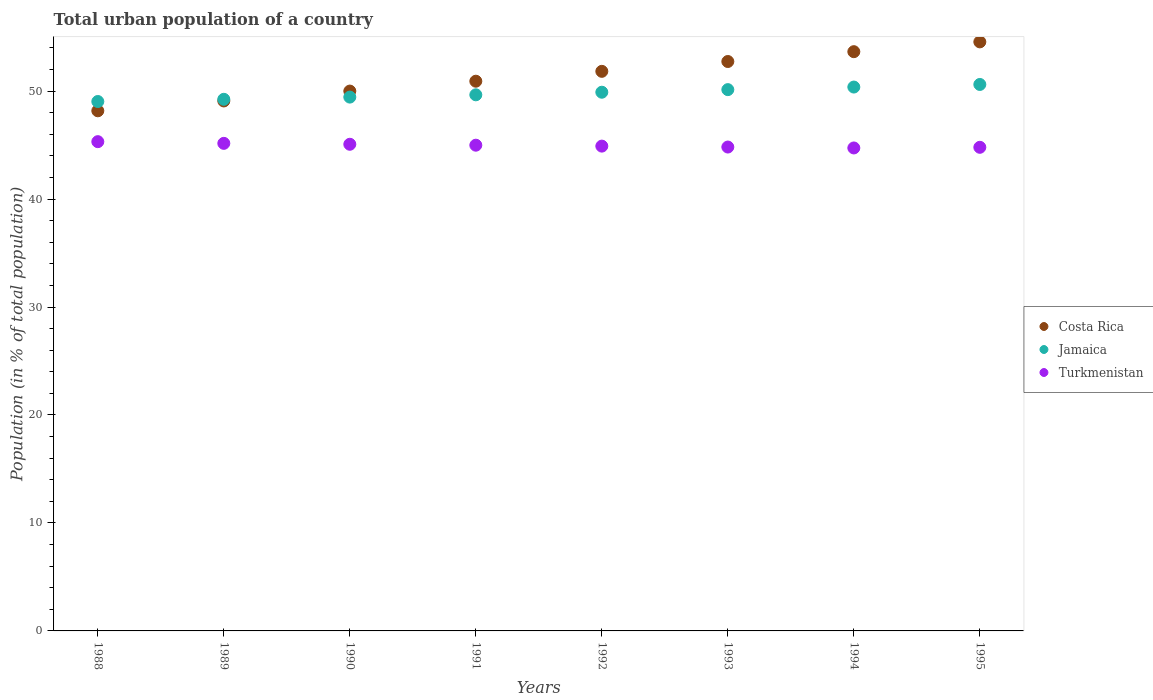What is the urban population in Costa Rica in 1994?
Offer a very short reply. 53.65. Across all years, what is the maximum urban population in Turkmenistan?
Provide a succinct answer. 45.32. Across all years, what is the minimum urban population in Turkmenistan?
Keep it short and to the point. 44.73. In which year was the urban population in Turkmenistan minimum?
Your response must be concise. 1994. What is the total urban population in Jamaica in the graph?
Give a very brief answer. 398.4. What is the difference between the urban population in Costa Rica in 1989 and that in 1991?
Your response must be concise. -1.83. What is the difference between the urban population in Costa Rica in 1991 and the urban population in Jamaica in 1990?
Provide a succinct answer. 1.47. What is the average urban population in Costa Rica per year?
Provide a succinct answer. 51.37. In the year 1990, what is the difference between the urban population in Jamaica and urban population in Costa Rica?
Make the answer very short. -0.56. What is the ratio of the urban population in Jamaica in 1994 to that in 1995?
Your answer should be compact. 1. Is the urban population in Costa Rica in 1988 less than that in 1994?
Give a very brief answer. Yes. Is the difference between the urban population in Jamaica in 1990 and 1992 greater than the difference between the urban population in Costa Rica in 1990 and 1992?
Your answer should be very brief. Yes. What is the difference between the highest and the second highest urban population in Costa Rica?
Provide a succinct answer. 0.91. What is the difference between the highest and the lowest urban population in Turkmenistan?
Your answer should be compact. 0.58. Is the sum of the urban population in Costa Rica in 1989 and 1990 greater than the maximum urban population in Jamaica across all years?
Give a very brief answer. Yes. Is it the case that in every year, the sum of the urban population in Turkmenistan and urban population in Costa Rica  is greater than the urban population in Jamaica?
Offer a terse response. Yes. Is the urban population in Costa Rica strictly greater than the urban population in Turkmenistan over the years?
Ensure brevity in your answer.  Yes. How many years are there in the graph?
Ensure brevity in your answer.  8. Are the values on the major ticks of Y-axis written in scientific E-notation?
Keep it short and to the point. No. Does the graph contain any zero values?
Keep it short and to the point. No. Does the graph contain grids?
Offer a very short reply. No. How are the legend labels stacked?
Give a very brief answer. Vertical. What is the title of the graph?
Provide a succinct answer. Total urban population of a country. What is the label or title of the Y-axis?
Ensure brevity in your answer.  Population (in % of total population). What is the Population (in % of total population) in Costa Rica in 1988?
Give a very brief answer. 48.18. What is the Population (in % of total population) of Jamaica in 1988?
Your answer should be compact. 49.04. What is the Population (in % of total population) of Turkmenistan in 1988?
Your answer should be compact. 45.32. What is the Population (in % of total population) of Costa Rica in 1989?
Offer a terse response. 49.09. What is the Population (in % of total population) of Jamaica in 1989?
Ensure brevity in your answer.  49.24. What is the Population (in % of total population) in Turkmenistan in 1989?
Give a very brief answer. 45.16. What is the Population (in % of total population) of Costa Rica in 1990?
Offer a very short reply. 50. What is the Population (in % of total population) in Jamaica in 1990?
Give a very brief answer. 49.44. What is the Population (in % of total population) of Turkmenistan in 1990?
Provide a short and direct response. 45.08. What is the Population (in % of total population) in Costa Rica in 1991?
Offer a terse response. 50.92. What is the Population (in % of total population) of Jamaica in 1991?
Provide a succinct answer. 49.66. What is the Population (in % of total population) in Turkmenistan in 1991?
Provide a succinct answer. 44.99. What is the Population (in % of total population) of Costa Rica in 1992?
Provide a short and direct response. 51.83. What is the Population (in % of total population) of Jamaica in 1992?
Keep it short and to the point. 49.9. What is the Population (in % of total population) of Turkmenistan in 1992?
Your answer should be compact. 44.9. What is the Population (in % of total population) of Costa Rica in 1993?
Your answer should be very brief. 52.74. What is the Population (in % of total population) of Jamaica in 1993?
Provide a succinct answer. 50.14. What is the Population (in % of total population) in Turkmenistan in 1993?
Ensure brevity in your answer.  44.82. What is the Population (in % of total population) in Costa Rica in 1994?
Ensure brevity in your answer.  53.65. What is the Population (in % of total population) in Jamaica in 1994?
Keep it short and to the point. 50.38. What is the Population (in % of total population) of Turkmenistan in 1994?
Provide a succinct answer. 44.73. What is the Population (in % of total population) of Costa Rica in 1995?
Your answer should be very brief. 54.56. What is the Population (in % of total population) in Jamaica in 1995?
Ensure brevity in your answer.  50.62. What is the Population (in % of total population) in Turkmenistan in 1995?
Offer a very short reply. 44.79. Across all years, what is the maximum Population (in % of total population) of Costa Rica?
Ensure brevity in your answer.  54.56. Across all years, what is the maximum Population (in % of total population) in Jamaica?
Offer a very short reply. 50.62. Across all years, what is the maximum Population (in % of total population) of Turkmenistan?
Your answer should be very brief. 45.32. Across all years, what is the minimum Population (in % of total population) of Costa Rica?
Provide a succinct answer. 48.18. Across all years, what is the minimum Population (in % of total population) of Jamaica?
Your answer should be very brief. 49.04. Across all years, what is the minimum Population (in % of total population) in Turkmenistan?
Make the answer very short. 44.73. What is the total Population (in % of total population) of Costa Rica in the graph?
Offer a very short reply. 410.96. What is the total Population (in % of total population) in Jamaica in the graph?
Ensure brevity in your answer.  398.4. What is the total Population (in % of total population) in Turkmenistan in the graph?
Make the answer very short. 359.79. What is the difference between the Population (in % of total population) in Costa Rica in 1988 and that in 1989?
Make the answer very short. -0.91. What is the difference between the Population (in % of total population) of Jamaica in 1988 and that in 1989?
Provide a short and direct response. -0.2. What is the difference between the Population (in % of total population) in Turkmenistan in 1988 and that in 1989?
Your answer should be very brief. 0.16. What is the difference between the Population (in % of total population) in Costa Rica in 1988 and that in 1990?
Make the answer very short. -1.83. What is the difference between the Population (in % of total population) of Jamaica in 1988 and that in 1990?
Your answer should be compact. -0.41. What is the difference between the Population (in % of total population) of Turkmenistan in 1988 and that in 1990?
Keep it short and to the point. 0.24. What is the difference between the Population (in % of total population) of Costa Rica in 1988 and that in 1991?
Your answer should be compact. -2.74. What is the difference between the Population (in % of total population) in Jamaica in 1988 and that in 1991?
Your answer should be compact. -0.62. What is the difference between the Population (in % of total population) of Turkmenistan in 1988 and that in 1991?
Your answer should be very brief. 0.33. What is the difference between the Population (in % of total population) of Costa Rica in 1988 and that in 1992?
Your answer should be very brief. -3.65. What is the difference between the Population (in % of total population) in Jamaica in 1988 and that in 1992?
Offer a very short reply. -0.86. What is the difference between the Population (in % of total population) in Turkmenistan in 1988 and that in 1992?
Offer a terse response. 0.41. What is the difference between the Population (in % of total population) in Costa Rica in 1988 and that in 1993?
Your answer should be compact. -4.57. What is the difference between the Population (in % of total population) in Turkmenistan in 1988 and that in 1993?
Your answer should be compact. 0.5. What is the difference between the Population (in % of total population) of Costa Rica in 1988 and that in 1994?
Make the answer very short. -5.47. What is the difference between the Population (in % of total population) in Jamaica in 1988 and that in 1994?
Your answer should be very brief. -1.34. What is the difference between the Population (in % of total population) of Turkmenistan in 1988 and that in 1994?
Ensure brevity in your answer.  0.58. What is the difference between the Population (in % of total population) in Costa Rica in 1988 and that in 1995?
Your response must be concise. -6.38. What is the difference between the Population (in % of total population) in Jamaica in 1988 and that in 1995?
Your answer should be very brief. -1.58. What is the difference between the Population (in % of total population) in Turkmenistan in 1988 and that in 1995?
Your answer should be very brief. 0.52. What is the difference between the Population (in % of total population) in Costa Rica in 1989 and that in 1990?
Give a very brief answer. -0.91. What is the difference between the Population (in % of total population) in Jamaica in 1989 and that in 1990?
Provide a succinct answer. -0.2. What is the difference between the Population (in % of total population) of Turkmenistan in 1989 and that in 1990?
Offer a terse response. 0.09. What is the difference between the Population (in % of total population) of Costa Rica in 1989 and that in 1991?
Make the answer very short. -1.83. What is the difference between the Population (in % of total population) of Jamaica in 1989 and that in 1991?
Offer a terse response. -0.42. What is the difference between the Population (in % of total population) of Turkmenistan in 1989 and that in 1991?
Provide a succinct answer. 0.17. What is the difference between the Population (in % of total population) of Costa Rica in 1989 and that in 1992?
Offer a very short reply. -2.74. What is the difference between the Population (in % of total population) of Jamaica in 1989 and that in 1992?
Offer a terse response. -0.66. What is the difference between the Population (in % of total population) in Turkmenistan in 1989 and that in 1992?
Offer a terse response. 0.26. What is the difference between the Population (in % of total population) in Costa Rica in 1989 and that in 1993?
Provide a short and direct response. -3.65. What is the difference between the Population (in % of total population) in Jamaica in 1989 and that in 1993?
Make the answer very short. -0.9. What is the difference between the Population (in % of total population) of Turkmenistan in 1989 and that in 1993?
Your response must be concise. 0.34. What is the difference between the Population (in % of total population) in Costa Rica in 1989 and that in 1994?
Your answer should be compact. -4.56. What is the difference between the Population (in % of total population) of Jamaica in 1989 and that in 1994?
Provide a succinct answer. -1.14. What is the difference between the Population (in % of total population) of Turkmenistan in 1989 and that in 1994?
Provide a short and direct response. 0.43. What is the difference between the Population (in % of total population) in Costa Rica in 1989 and that in 1995?
Ensure brevity in your answer.  -5.47. What is the difference between the Population (in % of total population) of Jamaica in 1989 and that in 1995?
Give a very brief answer. -1.38. What is the difference between the Population (in % of total population) of Turkmenistan in 1989 and that in 1995?
Offer a very short reply. 0.37. What is the difference between the Population (in % of total population) in Costa Rica in 1990 and that in 1991?
Provide a short and direct response. -0.91. What is the difference between the Population (in % of total population) in Jamaica in 1990 and that in 1991?
Keep it short and to the point. -0.21. What is the difference between the Population (in % of total population) in Turkmenistan in 1990 and that in 1991?
Offer a very short reply. 0.09. What is the difference between the Population (in % of total population) of Costa Rica in 1990 and that in 1992?
Your answer should be compact. -1.83. What is the difference between the Population (in % of total population) of Jamaica in 1990 and that in 1992?
Ensure brevity in your answer.  -0.45. What is the difference between the Population (in % of total population) in Turkmenistan in 1990 and that in 1992?
Offer a terse response. 0.17. What is the difference between the Population (in % of total population) of Costa Rica in 1990 and that in 1993?
Your answer should be very brief. -2.74. What is the difference between the Population (in % of total population) of Jamaica in 1990 and that in 1993?
Your answer should be compact. -0.69. What is the difference between the Population (in % of total population) of Turkmenistan in 1990 and that in 1993?
Your response must be concise. 0.26. What is the difference between the Population (in % of total population) in Costa Rica in 1990 and that in 1994?
Your answer should be very brief. -3.65. What is the difference between the Population (in % of total population) of Jamaica in 1990 and that in 1994?
Offer a terse response. -0.93. What is the difference between the Population (in % of total population) in Turkmenistan in 1990 and that in 1994?
Your answer should be very brief. 0.34. What is the difference between the Population (in % of total population) of Costa Rica in 1990 and that in 1995?
Provide a short and direct response. -4.56. What is the difference between the Population (in % of total population) of Jamaica in 1990 and that in 1995?
Your answer should be very brief. -1.17. What is the difference between the Population (in % of total population) in Turkmenistan in 1990 and that in 1995?
Provide a succinct answer. 0.28. What is the difference between the Population (in % of total population) of Costa Rica in 1991 and that in 1992?
Provide a short and direct response. -0.91. What is the difference between the Population (in % of total population) of Jamaica in 1991 and that in 1992?
Your answer should be very brief. -0.24. What is the difference between the Population (in % of total population) of Turkmenistan in 1991 and that in 1992?
Provide a short and direct response. 0.09. What is the difference between the Population (in % of total population) of Costa Rica in 1991 and that in 1993?
Ensure brevity in your answer.  -1.82. What is the difference between the Population (in % of total population) of Jamaica in 1991 and that in 1993?
Your answer should be very brief. -0.48. What is the difference between the Population (in % of total population) in Turkmenistan in 1991 and that in 1993?
Provide a short and direct response. 0.17. What is the difference between the Population (in % of total population) in Costa Rica in 1991 and that in 1994?
Provide a short and direct response. -2.73. What is the difference between the Population (in % of total population) in Jamaica in 1991 and that in 1994?
Keep it short and to the point. -0.72. What is the difference between the Population (in % of total population) in Turkmenistan in 1991 and that in 1994?
Give a very brief answer. 0.26. What is the difference between the Population (in % of total population) of Costa Rica in 1991 and that in 1995?
Ensure brevity in your answer.  -3.64. What is the difference between the Population (in % of total population) in Jamaica in 1991 and that in 1995?
Your answer should be very brief. -0.96. What is the difference between the Population (in % of total population) in Turkmenistan in 1991 and that in 1995?
Ensure brevity in your answer.  0.2. What is the difference between the Population (in % of total population) in Costa Rica in 1992 and that in 1993?
Offer a terse response. -0.91. What is the difference between the Population (in % of total population) in Jamaica in 1992 and that in 1993?
Provide a succinct answer. -0.24. What is the difference between the Population (in % of total population) of Turkmenistan in 1992 and that in 1993?
Offer a very short reply. 0.09. What is the difference between the Population (in % of total population) of Costa Rica in 1992 and that in 1994?
Give a very brief answer. -1.82. What is the difference between the Population (in % of total population) of Jamaica in 1992 and that in 1994?
Keep it short and to the point. -0.48. What is the difference between the Population (in % of total population) in Turkmenistan in 1992 and that in 1994?
Give a very brief answer. 0.17. What is the difference between the Population (in % of total population) of Costa Rica in 1992 and that in 1995?
Ensure brevity in your answer.  -2.73. What is the difference between the Population (in % of total population) of Jamaica in 1992 and that in 1995?
Make the answer very short. -0.72. What is the difference between the Population (in % of total population) in Turkmenistan in 1992 and that in 1995?
Make the answer very short. 0.11. What is the difference between the Population (in % of total population) of Costa Rica in 1993 and that in 1994?
Ensure brevity in your answer.  -0.91. What is the difference between the Population (in % of total population) of Jamaica in 1993 and that in 1994?
Offer a very short reply. -0.24. What is the difference between the Population (in % of total population) of Turkmenistan in 1993 and that in 1994?
Ensure brevity in your answer.  0.09. What is the difference between the Population (in % of total population) of Costa Rica in 1993 and that in 1995?
Offer a very short reply. -1.82. What is the difference between the Population (in % of total population) of Jamaica in 1993 and that in 1995?
Provide a short and direct response. -0.48. What is the difference between the Population (in % of total population) of Turkmenistan in 1993 and that in 1995?
Make the answer very short. 0.03. What is the difference between the Population (in % of total population) of Costa Rica in 1994 and that in 1995?
Offer a terse response. -0.91. What is the difference between the Population (in % of total population) in Jamaica in 1994 and that in 1995?
Ensure brevity in your answer.  -0.24. What is the difference between the Population (in % of total population) in Turkmenistan in 1994 and that in 1995?
Provide a short and direct response. -0.06. What is the difference between the Population (in % of total population) in Costa Rica in 1988 and the Population (in % of total population) in Jamaica in 1989?
Keep it short and to the point. -1.06. What is the difference between the Population (in % of total population) of Costa Rica in 1988 and the Population (in % of total population) of Turkmenistan in 1989?
Give a very brief answer. 3.02. What is the difference between the Population (in % of total population) in Jamaica in 1988 and the Population (in % of total population) in Turkmenistan in 1989?
Give a very brief answer. 3.88. What is the difference between the Population (in % of total population) in Costa Rica in 1988 and the Population (in % of total population) in Jamaica in 1990?
Your answer should be very brief. -1.27. What is the difference between the Population (in % of total population) of Costa Rica in 1988 and the Population (in % of total population) of Turkmenistan in 1990?
Your answer should be very brief. 3.1. What is the difference between the Population (in % of total population) of Jamaica in 1988 and the Population (in % of total population) of Turkmenistan in 1990?
Ensure brevity in your answer.  3.96. What is the difference between the Population (in % of total population) of Costa Rica in 1988 and the Population (in % of total population) of Jamaica in 1991?
Provide a succinct answer. -1.48. What is the difference between the Population (in % of total population) in Costa Rica in 1988 and the Population (in % of total population) in Turkmenistan in 1991?
Your answer should be compact. 3.19. What is the difference between the Population (in % of total population) in Jamaica in 1988 and the Population (in % of total population) in Turkmenistan in 1991?
Your response must be concise. 4.05. What is the difference between the Population (in % of total population) in Costa Rica in 1988 and the Population (in % of total population) in Jamaica in 1992?
Provide a short and direct response. -1.72. What is the difference between the Population (in % of total population) in Costa Rica in 1988 and the Population (in % of total population) in Turkmenistan in 1992?
Provide a succinct answer. 3.27. What is the difference between the Population (in % of total population) of Jamaica in 1988 and the Population (in % of total population) of Turkmenistan in 1992?
Your answer should be compact. 4.13. What is the difference between the Population (in % of total population) in Costa Rica in 1988 and the Population (in % of total population) in Jamaica in 1993?
Give a very brief answer. -1.96. What is the difference between the Population (in % of total population) in Costa Rica in 1988 and the Population (in % of total population) in Turkmenistan in 1993?
Offer a terse response. 3.36. What is the difference between the Population (in % of total population) of Jamaica in 1988 and the Population (in % of total population) of Turkmenistan in 1993?
Offer a terse response. 4.22. What is the difference between the Population (in % of total population) of Costa Rica in 1988 and the Population (in % of total population) of Jamaica in 1994?
Make the answer very short. -2.2. What is the difference between the Population (in % of total population) of Costa Rica in 1988 and the Population (in % of total population) of Turkmenistan in 1994?
Provide a succinct answer. 3.44. What is the difference between the Population (in % of total population) in Jamaica in 1988 and the Population (in % of total population) in Turkmenistan in 1994?
Your answer should be compact. 4.3. What is the difference between the Population (in % of total population) in Costa Rica in 1988 and the Population (in % of total population) in Jamaica in 1995?
Your response must be concise. -2.44. What is the difference between the Population (in % of total population) of Costa Rica in 1988 and the Population (in % of total population) of Turkmenistan in 1995?
Ensure brevity in your answer.  3.38. What is the difference between the Population (in % of total population) of Jamaica in 1988 and the Population (in % of total population) of Turkmenistan in 1995?
Offer a very short reply. 4.24. What is the difference between the Population (in % of total population) in Costa Rica in 1989 and the Population (in % of total population) in Jamaica in 1990?
Provide a short and direct response. -0.36. What is the difference between the Population (in % of total population) in Costa Rica in 1989 and the Population (in % of total population) in Turkmenistan in 1990?
Your answer should be compact. 4.01. What is the difference between the Population (in % of total population) in Jamaica in 1989 and the Population (in % of total population) in Turkmenistan in 1990?
Your answer should be compact. 4.17. What is the difference between the Population (in % of total population) of Costa Rica in 1989 and the Population (in % of total population) of Jamaica in 1991?
Ensure brevity in your answer.  -0.57. What is the difference between the Population (in % of total population) of Costa Rica in 1989 and the Population (in % of total population) of Turkmenistan in 1991?
Your answer should be very brief. 4.1. What is the difference between the Population (in % of total population) of Jamaica in 1989 and the Population (in % of total population) of Turkmenistan in 1991?
Keep it short and to the point. 4.25. What is the difference between the Population (in % of total population) of Costa Rica in 1989 and the Population (in % of total population) of Jamaica in 1992?
Your response must be concise. -0.81. What is the difference between the Population (in % of total population) in Costa Rica in 1989 and the Population (in % of total population) in Turkmenistan in 1992?
Ensure brevity in your answer.  4.18. What is the difference between the Population (in % of total population) in Jamaica in 1989 and the Population (in % of total population) in Turkmenistan in 1992?
Make the answer very short. 4.34. What is the difference between the Population (in % of total population) of Costa Rica in 1989 and the Population (in % of total population) of Jamaica in 1993?
Your answer should be compact. -1.05. What is the difference between the Population (in % of total population) in Costa Rica in 1989 and the Population (in % of total population) in Turkmenistan in 1993?
Provide a short and direct response. 4.27. What is the difference between the Population (in % of total population) in Jamaica in 1989 and the Population (in % of total population) in Turkmenistan in 1993?
Offer a terse response. 4.42. What is the difference between the Population (in % of total population) of Costa Rica in 1989 and the Population (in % of total population) of Jamaica in 1994?
Keep it short and to the point. -1.29. What is the difference between the Population (in % of total population) in Costa Rica in 1989 and the Population (in % of total population) in Turkmenistan in 1994?
Your response must be concise. 4.35. What is the difference between the Population (in % of total population) of Jamaica in 1989 and the Population (in % of total population) of Turkmenistan in 1994?
Keep it short and to the point. 4.51. What is the difference between the Population (in % of total population) in Costa Rica in 1989 and the Population (in % of total population) in Jamaica in 1995?
Your answer should be compact. -1.53. What is the difference between the Population (in % of total population) of Costa Rica in 1989 and the Population (in % of total population) of Turkmenistan in 1995?
Your answer should be compact. 4.29. What is the difference between the Population (in % of total population) of Jamaica in 1989 and the Population (in % of total population) of Turkmenistan in 1995?
Give a very brief answer. 4.45. What is the difference between the Population (in % of total population) of Costa Rica in 1990 and the Population (in % of total population) of Jamaica in 1991?
Ensure brevity in your answer.  0.35. What is the difference between the Population (in % of total population) in Costa Rica in 1990 and the Population (in % of total population) in Turkmenistan in 1991?
Your answer should be very brief. 5.01. What is the difference between the Population (in % of total population) in Jamaica in 1990 and the Population (in % of total population) in Turkmenistan in 1991?
Offer a terse response. 4.45. What is the difference between the Population (in % of total population) in Costa Rica in 1990 and the Population (in % of total population) in Jamaica in 1992?
Offer a terse response. 0.11. What is the difference between the Population (in % of total population) of Costa Rica in 1990 and the Population (in % of total population) of Turkmenistan in 1992?
Offer a terse response. 5.1. What is the difference between the Population (in % of total population) of Jamaica in 1990 and the Population (in % of total population) of Turkmenistan in 1992?
Your response must be concise. 4.54. What is the difference between the Population (in % of total population) of Costa Rica in 1990 and the Population (in % of total population) of Jamaica in 1993?
Your answer should be very brief. -0.13. What is the difference between the Population (in % of total population) of Costa Rica in 1990 and the Population (in % of total population) of Turkmenistan in 1993?
Offer a very short reply. 5.18. What is the difference between the Population (in % of total population) of Jamaica in 1990 and the Population (in % of total population) of Turkmenistan in 1993?
Your answer should be compact. 4.62. What is the difference between the Population (in % of total population) of Costa Rica in 1990 and the Population (in % of total population) of Jamaica in 1994?
Your answer should be very brief. -0.37. What is the difference between the Population (in % of total population) of Costa Rica in 1990 and the Population (in % of total population) of Turkmenistan in 1994?
Offer a terse response. 5.27. What is the difference between the Population (in % of total population) of Jamaica in 1990 and the Population (in % of total population) of Turkmenistan in 1994?
Give a very brief answer. 4.71. What is the difference between the Population (in % of total population) in Costa Rica in 1990 and the Population (in % of total population) in Jamaica in 1995?
Ensure brevity in your answer.  -0.61. What is the difference between the Population (in % of total population) in Costa Rica in 1990 and the Population (in % of total population) in Turkmenistan in 1995?
Your answer should be very brief. 5.21. What is the difference between the Population (in % of total population) of Jamaica in 1990 and the Population (in % of total population) of Turkmenistan in 1995?
Keep it short and to the point. 4.65. What is the difference between the Population (in % of total population) in Costa Rica in 1991 and the Population (in % of total population) in Jamaica in 1992?
Your answer should be very brief. 1.02. What is the difference between the Population (in % of total population) of Costa Rica in 1991 and the Population (in % of total population) of Turkmenistan in 1992?
Provide a short and direct response. 6.01. What is the difference between the Population (in % of total population) in Jamaica in 1991 and the Population (in % of total population) in Turkmenistan in 1992?
Offer a terse response. 4.75. What is the difference between the Population (in % of total population) of Costa Rica in 1991 and the Population (in % of total population) of Jamaica in 1993?
Give a very brief answer. 0.78. What is the difference between the Population (in % of total population) in Costa Rica in 1991 and the Population (in % of total population) in Turkmenistan in 1993?
Offer a very short reply. 6.1. What is the difference between the Population (in % of total population) in Jamaica in 1991 and the Population (in % of total population) in Turkmenistan in 1993?
Offer a terse response. 4.84. What is the difference between the Population (in % of total population) of Costa Rica in 1991 and the Population (in % of total population) of Jamaica in 1994?
Your answer should be compact. 0.54. What is the difference between the Population (in % of total population) in Costa Rica in 1991 and the Population (in % of total population) in Turkmenistan in 1994?
Make the answer very short. 6.18. What is the difference between the Population (in % of total population) in Jamaica in 1991 and the Population (in % of total population) in Turkmenistan in 1994?
Provide a short and direct response. 4.92. What is the difference between the Population (in % of total population) in Costa Rica in 1991 and the Population (in % of total population) in Jamaica in 1995?
Provide a short and direct response. 0.3. What is the difference between the Population (in % of total population) of Costa Rica in 1991 and the Population (in % of total population) of Turkmenistan in 1995?
Your answer should be compact. 6.12. What is the difference between the Population (in % of total population) in Jamaica in 1991 and the Population (in % of total population) in Turkmenistan in 1995?
Ensure brevity in your answer.  4.86. What is the difference between the Population (in % of total population) in Costa Rica in 1992 and the Population (in % of total population) in Jamaica in 1993?
Keep it short and to the point. 1.69. What is the difference between the Population (in % of total population) of Costa Rica in 1992 and the Population (in % of total population) of Turkmenistan in 1993?
Keep it short and to the point. 7.01. What is the difference between the Population (in % of total population) in Jamaica in 1992 and the Population (in % of total population) in Turkmenistan in 1993?
Provide a succinct answer. 5.08. What is the difference between the Population (in % of total population) in Costa Rica in 1992 and the Population (in % of total population) in Jamaica in 1994?
Offer a terse response. 1.46. What is the difference between the Population (in % of total population) of Costa Rica in 1992 and the Population (in % of total population) of Turkmenistan in 1994?
Offer a very short reply. 7.1. What is the difference between the Population (in % of total population) in Jamaica in 1992 and the Population (in % of total population) in Turkmenistan in 1994?
Provide a short and direct response. 5.16. What is the difference between the Population (in % of total population) in Costa Rica in 1992 and the Population (in % of total population) in Jamaica in 1995?
Make the answer very short. 1.22. What is the difference between the Population (in % of total population) in Costa Rica in 1992 and the Population (in % of total population) in Turkmenistan in 1995?
Keep it short and to the point. 7.04. What is the difference between the Population (in % of total population) in Jamaica in 1992 and the Population (in % of total population) in Turkmenistan in 1995?
Keep it short and to the point. 5.1. What is the difference between the Population (in % of total population) in Costa Rica in 1993 and the Population (in % of total population) in Jamaica in 1994?
Give a very brief answer. 2.37. What is the difference between the Population (in % of total population) of Costa Rica in 1993 and the Population (in % of total population) of Turkmenistan in 1994?
Ensure brevity in your answer.  8.01. What is the difference between the Population (in % of total population) of Jamaica in 1993 and the Population (in % of total population) of Turkmenistan in 1994?
Your response must be concise. 5.4. What is the difference between the Population (in % of total population) of Costa Rica in 1993 and the Population (in % of total population) of Jamaica in 1995?
Provide a succinct answer. 2.13. What is the difference between the Population (in % of total population) of Costa Rica in 1993 and the Population (in % of total population) of Turkmenistan in 1995?
Keep it short and to the point. 7.95. What is the difference between the Population (in % of total population) in Jamaica in 1993 and the Population (in % of total population) in Turkmenistan in 1995?
Give a very brief answer. 5.34. What is the difference between the Population (in % of total population) in Costa Rica in 1994 and the Population (in % of total population) in Jamaica in 1995?
Give a very brief answer. 3.04. What is the difference between the Population (in % of total population) of Costa Rica in 1994 and the Population (in % of total population) of Turkmenistan in 1995?
Make the answer very short. 8.86. What is the difference between the Population (in % of total population) in Jamaica in 1994 and the Population (in % of total population) in Turkmenistan in 1995?
Keep it short and to the point. 5.58. What is the average Population (in % of total population) in Costa Rica per year?
Offer a terse response. 51.37. What is the average Population (in % of total population) in Jamaica per year?
Ensure brevity in your answer.  49.8. What is the average Population (in % of total population) of Turkmenistan per year?
Keep it short and to the point. 44.97. In the year 1988, what is the difference between the Population (in % of total population) of Costa Rica and Population (in % of total population) of Jamaica?
Offer a very short reply. -0.86. In the year 1988, what is the difference between the Population (in % of total population) in Costa Rica and Population (in % of total population) in Turkmenistan?
Keep it short and to the point. 2.86. In the year 1988, what is the difference between the Population (in % of total population) in Jamaica and Population (in % of total population) in Turkmenistan?
Offer a terse response. 3.72. In the year 1989, what is the difference between the Population (in % of total population) in Costa Rica and Population (in % of total population) in Jamaica?
Provide a short and direct response. -0.15. In the year 1989, what is the difference between the Population (in % of total population) in Costa Rica and Population (in % of total population) in Turkmenistan?
Offer a terse response. 3.93. In the year 1989, what is the difference between the Population (in % of total population) of Jamaica and Population (in % of total population) of Turkmenistan?
Provide a short and direct response. 4.08. In the year 1990, what is the difference between the Population (in % of total population) in Costa Rica and Population (in % of total population) in Jamaica?
Provide a short and direct response. 0.56. In the year 1990, what is the difference between the Population (in % of total population) of Costa Rica and Population (in % of total population) of Turkmenistan?
Keep it short and to the point. 4.93. In the year 1990, what is the difference between the Population (in % of total population) of Jamaica and Population (in % of total population) of Turkmenistan?
Provide a succinct answer. 4.37. In the year 1991, what is the difference between the Population (in % of total population) in Costa Rica and Population (in % of total population) in Jamaica?
Your answer should be compact. 1.26. In the year 1991, what is the difference between the Population (in % of total population) in Costa Rica and Population (in % of total population) in Turkmenistan?
Keep it short and to the point. 5.93. In the year 1991, what is the difference between the Population (in % of total population) in Jamaica and Population (in % of total population) in Turkmenistan?
Your answer should be compact. 4.67. In the year 1992, what is the difference between the Population (in % of total population) in Costa Rica and Population (in % of total population) in Jamaica?
Keep it short and to the point. 1.93. In the year 1992, what is the difference between the Population (in % of total population) in Costa Rica and Population (in % of total population) in Turkmenistan?
Keep it short and to the point. 6.93. In the year 1992, what is the difference between the Population (in % of total population) in Jamaica and Population (in % of total population) in Turkmenistan?
Keep it short and to the point. 4.99. In the year 1993, what is the difference between the Population (in % of total population) of Costa Rica and Population (in % of total population) of Jamaica?
Make the answer very short. 2.6. In the year 1993, what is the difference between the Population (in % of total population) in Costa Rica and Population (in % of total population) in Turkmenistan?
Your answer should be compact. 7.92. In the year 1993, what is the difference between the Population (in % of total population) of Jamaica and Population (in % of total population) of Turkmenistan?
Provide a succinct answer. 5.32. In the year 1994, what is the difference between the Population (in % of total population) in Costa Rica and Population (in % of total population) in Jamaica?
Make the answer very short. 3.28. In the year 1994, what is the difference between the Population (in % of total population) of Costa Rica and Population (in % of total population) of Turkmenistan?
Your response must be concise. 8.92. In the year 1994, what is the difference between the Population (in % of total population) of Jamaica and Population (in % of total population) of Turkmenistan?
Your answer should be compact. 5.64. In the year 1995, what is the difference between the Population (in % of total population) of Costa Rica and Population (in % of total population) of Jamaica?
Make the answer very short. 3.94. In the year 1995, what is the difference between the Population (in % of total population) of Costa Rica and Population (in % of total population) of Turkmenistan?
Your response must be concise. 9.77. In the year 1995, what is the difference between the Population (in % of total population) in Jamaica and Population (in % of total population) in Turkmenistan?
Give a very brief answer. 5.82. What is the ratio of the Population (in % of total population) of Costa Rica in 1988 to that in 1989?
Provide a succinct answer. 0.98. What is the ratio of the Population (in % of total population) of Costa Rica in 1988 to that in 1990?
Make the answer very short. 0.96. What is the ratio of the Population (in % of total population) of Turkmenistan in 1988 to that in 1990?
Provide a short and direct response. 1.01. What is the ratio of the Population (in % of total population) in Costa Rica in 1988 to that in 1991?
Offer a terse response. 0.95. What is the ratio of the Population (in % of total population) of Jamaica in 1988 to that in 1991?
Ensure brevity in your answer.  0.99. What is the ratio of the Population (in % of total population) of Turkmenistan in 1988 to that in 1991?
Offer a terse response. 1.01. What is the ratio of the Population (in % of total population) of Costa Rica in 1988 to that in 1992?
Give a very brief answer. 0.93. What is the ratio of the Population (in % of total population) of Jamaica in 1988 to that in 1992?
Your answer should be very brief. 0.98. What is the ratio of the Population (in % of total population) in Turkmenistan in 1988 to that in 1992?
Your response must be concise. 1.01. What is the ratio of the Population (in % of total population) in Costa Rica in 1988 to that in 1993?
Your response must be concise. 0.91. What is the ratio of the Population (in % of total population) in Jamaica in 1988 to that in 1993?
Ensure brevity in your answer.  0.98. What is the ratio of the Population (in % of total population) of Turkmenistan in 1988 to that in 1993?
Provide a succinct answer. 1.01. What is the ratio of the Population (in % of total population) of Costa Rica in 1988 to that in 1994?
Your answer should be compact. 0.9. What is the ratio of the Population (in % of total population) in Jamaica in 1988 to that in 1994?
Provide a short and direct response. 0.97. What is the ratio of the Population (in % of total population) of Turkmenistan in 1988 to that in 1994?
Offer a very short reply. 1.01. What is the ratio of the Population (in % of total population) of Costa Rica in 1988 to that in 1995?
Your answer should be compact. 0.88. What is the ratio of the Population (in % of total population) in Jamaica in 1988 to that in 1995?
Your answer should be compact. 0.97. What is the ratio of the Population (in % of total population) in Turkmenistan in 1988 to that in 1995?
Your response must be concise. 1.01. What is the ratio of the Population (in % of total population) in Costa Rica in 1989 to that in 1990?
Ensure brevity in your answer.  0.98. What is the ratio of the Population (in % of total population) in Turkmenistan in 1989 to that in 1990?
Offer a terse response. 1. What is the ratio of the Population (in % of total population) of Costa Rica in 1989 to that in 1991?
Offer a terse response. 0.96. What is the ratio of the Population (in % of total population) of Jamaica in 1989 to that in 1991?
Your answer should be very brief. 0.99. What is the ratio of the Population (in % of total population) in Turkmenistan in 1989 to that in 1991?
Keep it short and to the point. 1. What is the ratio of the Population (in % of total population) in Costa Rica in 1989 to that in 1992?
Ensure brevity in your answer.  0.95. What is the ratio of the Population (in % of total population) in Jamaica in 1989 to that in 1992?
Your answer should be very brief. 0.99. What is the ratio of the Population (in % of total population) of Costa Rica in 1989 to that in 1993?
Provide a short and direct response. 0.93. What is the ratio of the Population (in % of total population) of Jamaica in 1989 to that in 1993?
Make the answer very short. 0.98. What is the ratio of the Population (in % of total population) in Turkmenistan in 1989 to that in 1993?
Offer a terse response. 1.01. What is the ratio of the Population (in % of total population) in Costa Rica in 1989 to that in 1994?
Give a very brief answer. 0.92. What is the ratio of the Population (in % of total population) of Jamaica in 1989 to that in 1994?
Your answer should be very brief. 0.98. What is the ratio of the Population (in % of total population) of Turkmenistan in 1989 to that in 1994?
Offer a terse response. 1.01. What is the ratio of the Population (in % of total population) of Costa Rica in 1989 to that in 1995?
Your response must be concise. 0.9. What is the ratio of the Population (in % of total population) of Jamaica in 1989 to that in 1995?
Keep it short and to the point. 0.97. What is the ratio of the Population (in % of total population) of Turkmenistan in 1989 to that in 1995?
Ensure brevity in your answer.  1.01. What is the ratio of the Population (in % of total population) in Jamaica in 1990 to that in 1991?
Make the answer very short. 1. What is the ratio of the Population (in % of total population) of Costa Rica in 1990 to that in 1992?
Your answer should be compact. 0.96. What is the ratio of the Population (in % of total population) in Jamaica in 1990 to that in 1992?
Provide a short and direct response. 0.99. What is the ratio of the Population (in % of total population) in Turkmenistan in 1990 to that in 1992?
Offer a terse response. 1. What is the ratio of the Population (in % of total population) in Costa Rica in 1990 to that in 1993?
Your answer should be compact. 0.95. What is the ratio of the Population (in % of total population) of Jamaica in 1990 to that in 1993?
Offer a very short reply. 0.99. What is the ratio of the Population (in % of total population) of Costa Rica in 1990 to that in 1994?
Provide a succinct answer. 0.93. What is the ratio of the Population (in % of total population) of Jamaica in 1990 to that in 1994?
Your response must be concise. 0.98. What is the ratio of the Population (in % of total population) in Turkmenistan in 1990 to that in 1994?
Your answer should be very brief. 1.01. What is the ratio of the Population (in % of total population) of Costa Rica in 1990 to that in 1995?
Your answer should be compact. 0.92. What is the ratio of the Population (in % of total population) in Jamaica in 1990 to that in 1995?
Make the answer very short. 0.98. What is the ratio of the Population (in % of total population) in Turkmenistan in 1990 to that in 1995?
Give a very brief answer. 1.01. What is the ratio of the Population (in % of total population) of Costa Rica in 1991 to that in 1992?
Your response must be concise. 0.98. What is the ratio of the Population (in % of total population) in Turkmenistan in 1991 to that in 1992?
Keep it short and to the point. 1. What is the ratio of the Population (in % of total population) in Costa Rica in 1991 to that in 1993?
Offer a terse response. 0.97. What is the ratio of the Population (in % of total population) in Jamaica in 1991 to that in 1993?
Offer a terse response. 0.99. What is the ratio of the Population (in % of total population) of Turkmenistan in 1991 to that in 1993?
Give a very brief answer. 1. What is the ratio of the Population (in % of total population) of Costa Rica in 1991 to that in 1994?
Your answer should be compact. 0.95. What is the ratio of the Population (in % of total population) in Jamaica in 1991 to that in 1994?
Your answer should be compact. 0.99. What is the ratio of the Population (in % of total population) of Turkmenistan in 1991 to that in 1994?
Your response must be concise. 1.01. What is the ratio of the Population (in % of total population) in Costa Rica in 1991 to that in 1995?
Give a very brief answer. 0.93. What is the ratio of the Population (in % of total population) of Jamaica in 1991 to that in 1995?
Offer a terse response. 0.98. What is the ratio of the Population (in % of total population) of Turkmenistan in 1991 to that in 1995?
Offer a very short reply. 1. What is the ratio of the Population (in % of total population) of Costa Rica in 1992 to that in 1993?
Keep it short and to the point. 0.98. What is the ratio of the Population (in % of total population) of Jamaica in 1992 to that in 1993?
Provide a short and direct response. 1. What is the ratio of the Population (in % of total population) in Turkmenistan in 1992 to that in 1993?
Your answer should be very brief. 1. What is the ratio of the Population (in % of total population) in Costa Rica in 1992 to that in 1994?
Keep it short and to the point. 0.97. What is the ratio of the Population (in % of total population) of Jamaica in 1992 to that in 1994?
Your response must be concise. 0.99. What is the ratio of the Population (in % of total population) in Turkmenistan in 1992 to that in 1994?
Your answer should be very brief. 1. What is the ratio of the Population (in % of total population) in Costa Rica in 1992 to that in 1995?
Give a very brief answer. 0.95. What is the ratio of the Population (in % of total population) in Jamaica in 1992 to that in 1995?
Offer a terse response. 0.99. What is the ratio of the Population (in % of total population) of Turkmenistan in 1993 to that in 1994?
Provide a short and direct response. 1. What is the ratio of the Population (in % of total population) of Costa Rica in 1993 to that in 1995?
Make the answer very short. 0.97. What is the ratio of the Population (in % of total population) in Jamaica in 1993 to that in 1995?
Your response must be concise. 0.99. What is the ratio of the Population (in % of total population) of Costa Rica in 1994 to that in 1995?
Offer a very short reply. 0.98. What is the ratio of the Population (in % of total population) of Jamaica in 1994 to that in 1995?
Offer a very short reply. 1. What is the difference between the highest and the second highest Population (in % of total population) of Costa Rica?
Provide a short and direct response. 0.91. What is the difference between the highest and the second highest Population (in % of total population) of Jamaica?
Make the answer very short. 0.24. What is the difference between the highest and the second highest Population (in % of total population) of Turkmenistan?
Make the answer very short. 0.16. What is the difference between the highest and the lowest Population (in % of total population) in Costa Rica?
Keep it short and to the point. 6.38. What is the difference between the highest and the lowest Population (in % of total population) in Jamaica?
Provide a succinct answer. 1.58. What is the difference between the highest and the lowest Population (in % of total population) in Turkmenistan?
Ensure brevity in your answer.  0.58. 